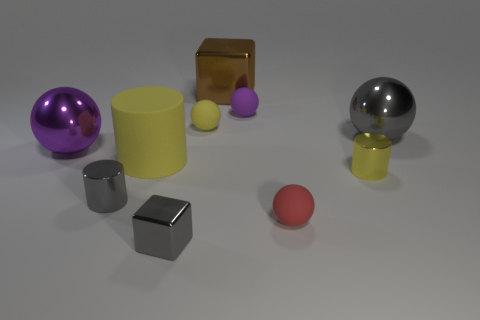Subtract all small purple balls. How many balls are left? 4 Subtract all gray cylinders. How many cylinders are left? 2 Subtract 1 cylinders. How many cylinders are left? 2 Subtract all red blocks. How many yellow cylinders are left? 2 Subtract all brown blocks. Subtract all tiny gray things. How many objects are left? 7 Add 7 metallic cubes. How many metallic cubes are left? 9 Add 4 small metallic cylinders. How many small metallic cylinders exist? 6 Subtract 1 yellow spheres. How many objects are left? 9 Subtract all cylinders. How many objects are left? 7 Subtract all blue spheres. Subtract all yellow cylinders. How many spheres are left? 5 